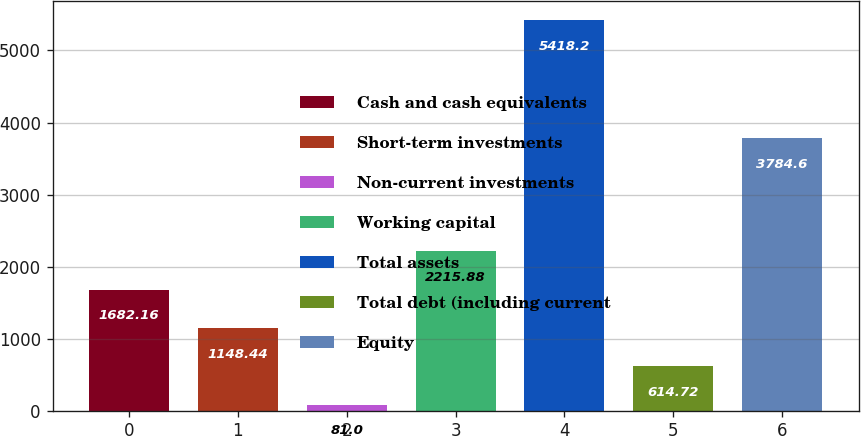<chart> <loc_0><loc_0><loc_500><loc_500><bar_chart><fcel>Cash and cash equivalents<fcel>Short-term investments<fcel>Non-current investments<fcel>Working capital<fcel>Total assets<fcel>Total debt (including current<fcel>Equity<nl><fcel>1682.16<fcel>1148.44<fcel>81<fcel>2215.88<fcel>5418.2<fcel>614.72<fcel>3784.6<nl></chart> 